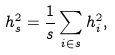<formula> <loc_0><loc_0><loc_500><loc_500>h _ { s } ^ { 2 } = \frac { 1 } { s } \sum _ { i \in s } h _ { i } ^ { 2 } ,</formula> 